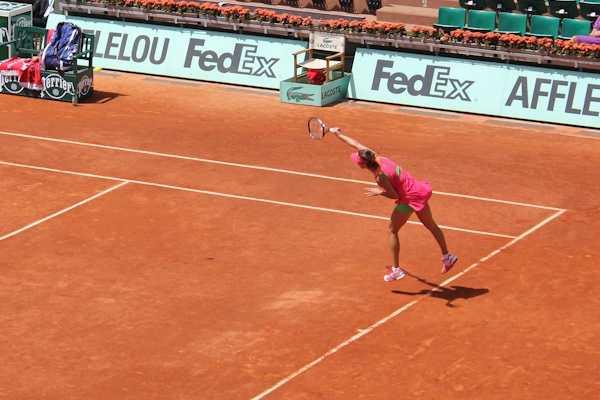Describe the objects in this image and their specific colors. I can see people in black, salmon, maroon, brown, and red tones, bench in black, gray, teal, and darkgray tones, chair in black, ivory, darkgray, and tan tones, backpack in black, blue, navy, and gray tones, and potted plant in black, maroon, and gray tones in this image. 